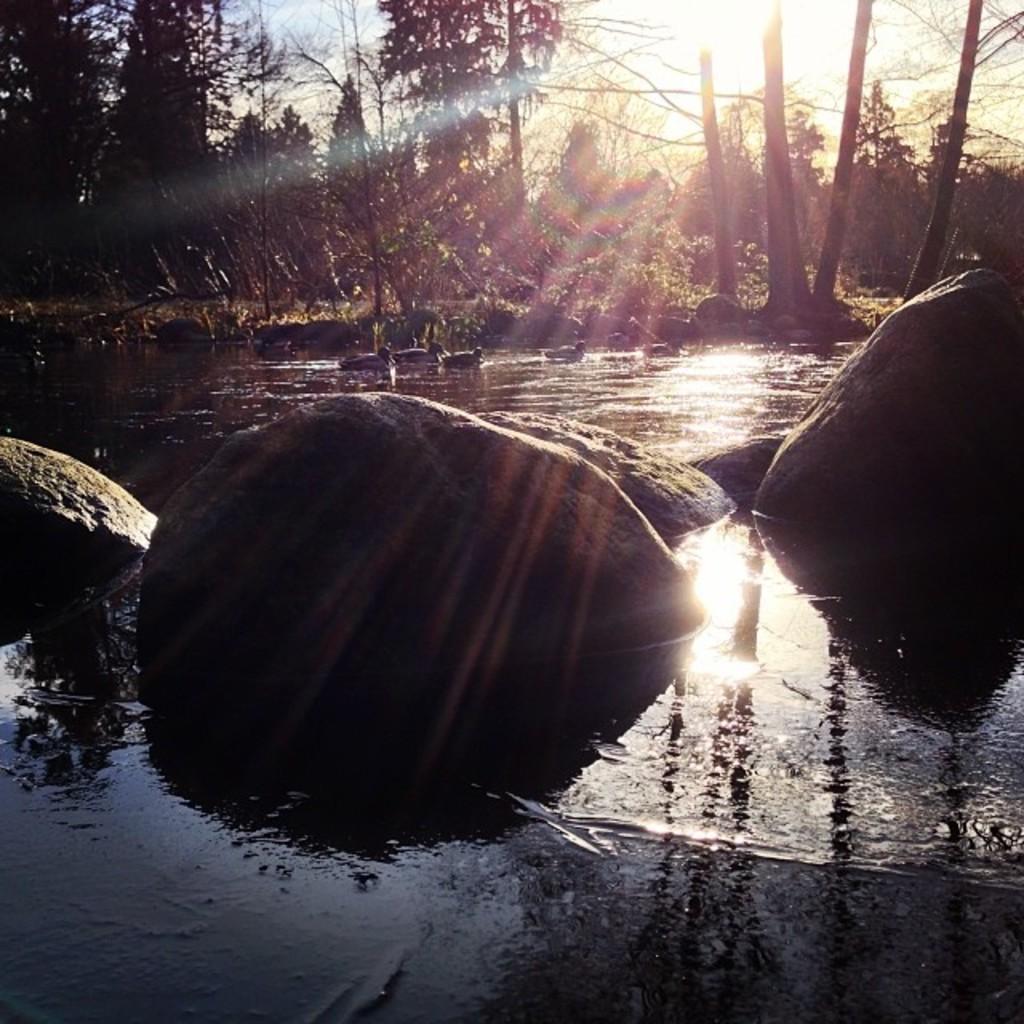Can you describe this image briefly? In this image we can see rocks, water, ducks, trees, plants, sky and sun. 